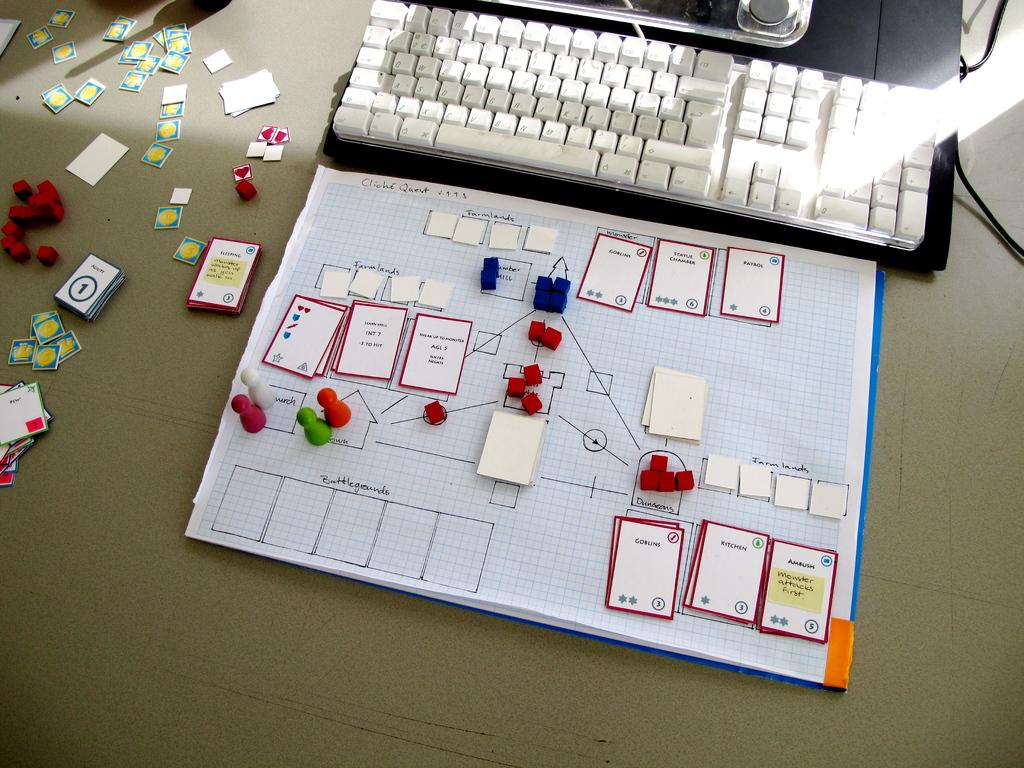<image>
Offer a succinct explanation of the picture presented. a set of cards on a paper with one of them that says 'goblins' 